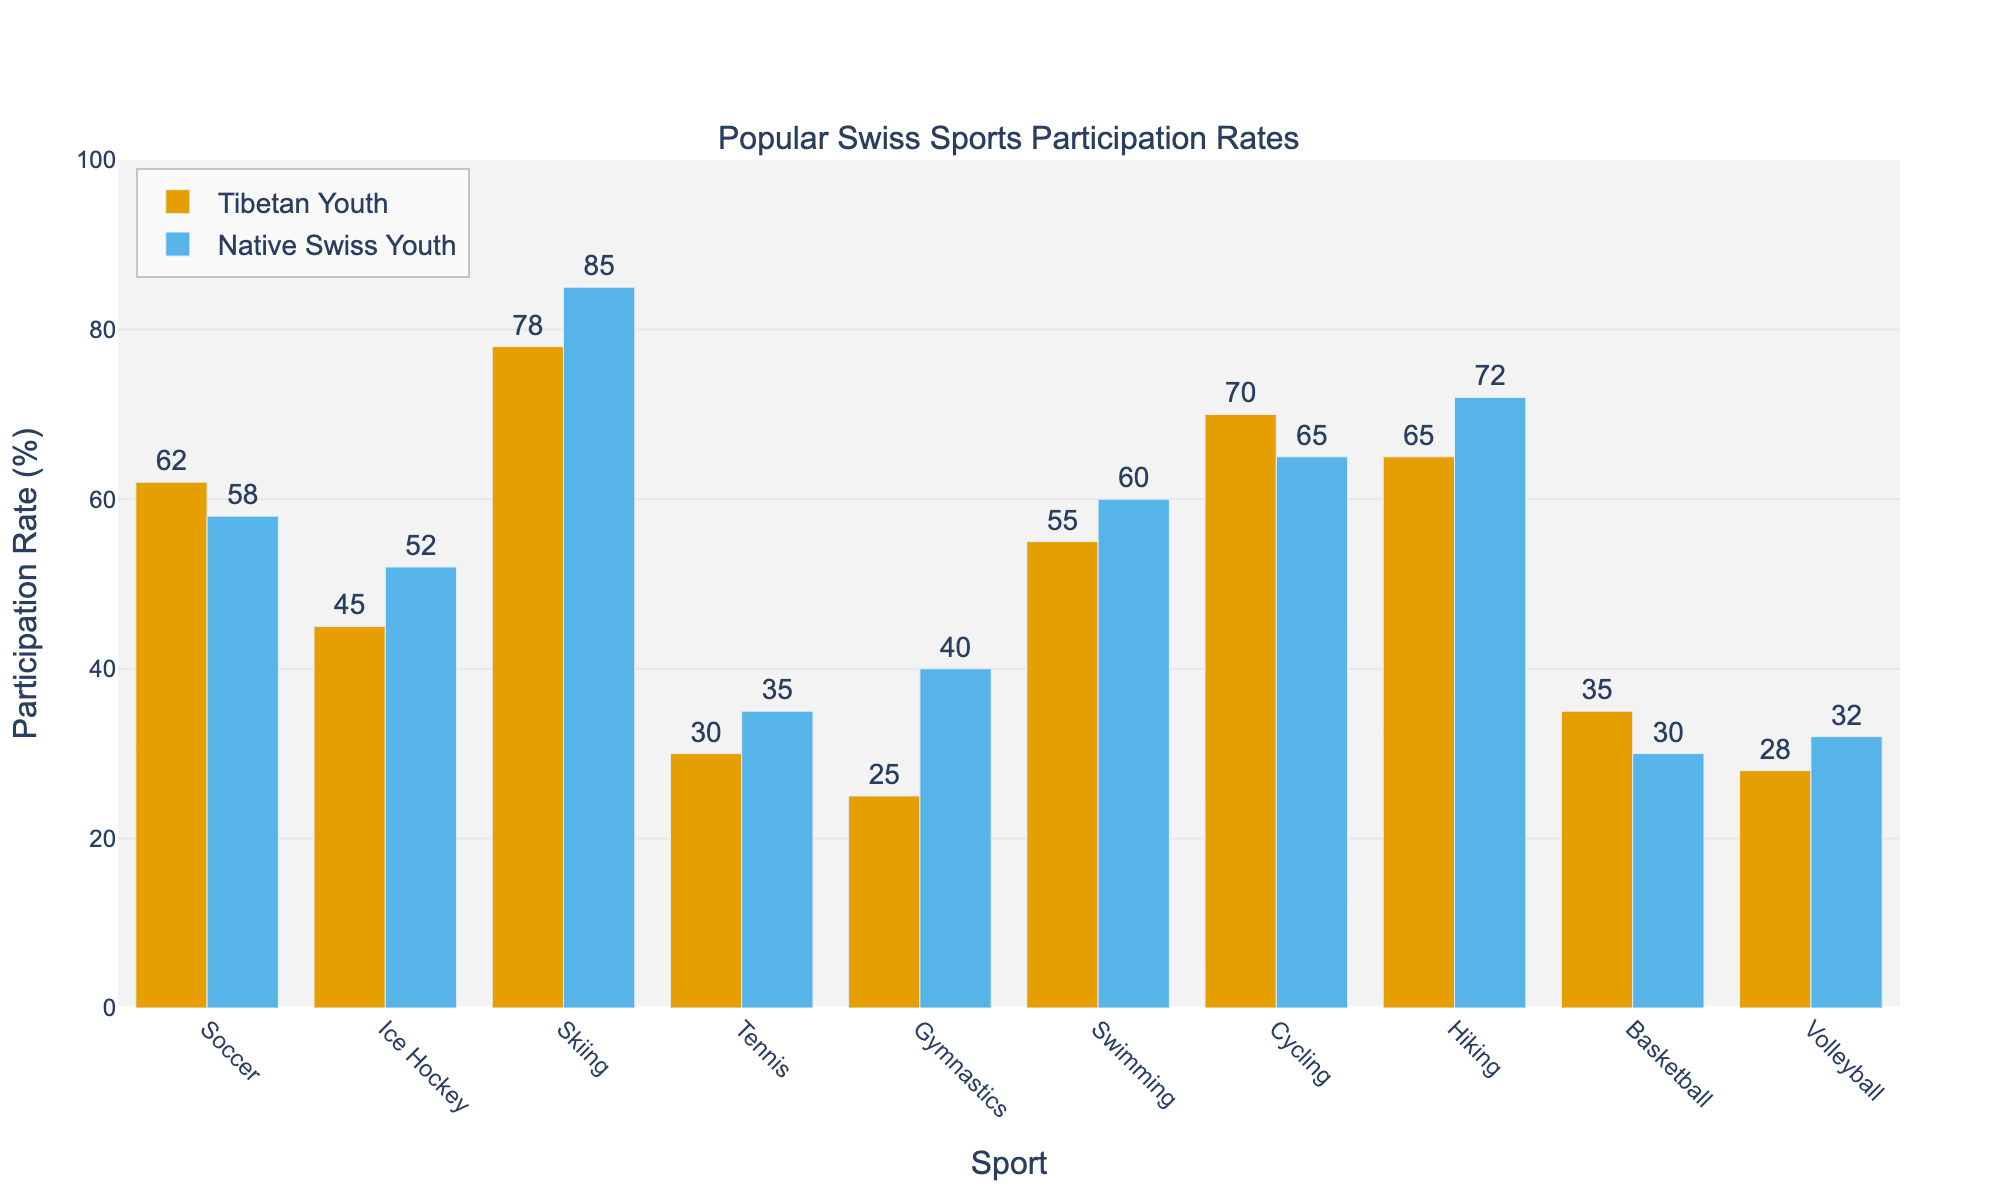Which sport has the highest participation rate among Tibetan youth? We look for the tallest bar representing Tibetan youth in the figure, which corresponds to the sport with the highest participation rate. The tallest bar among Tibetan youth is for Skiing, which has a participation rate of 78%.
Answer: Skiing Which group has a higher participation rate in basketball? We compare the heights of the two bars representing basketball. The Tibetan youth bar is taller, indicating a higher participation rate in basketball (35%) compared to native Swiss youth (30%).
Answer: Tibetan Youth What is the difference in participation rates for gymnastics between Tibetan and native Swiss youth? We subtract the participation rate of Tibetan youth (25%) from that of native Swiss youth (40%) for gymnastics. 40% - 25% = 15%.
Answer: 15% Which sport has the smallest difference in participation rates between Tibetan and native Swiss youth? We compare the absolute differences in participation rates for each sport. Basketball has the smallest difference:
Answer: Basketball What is the average participation rate for swimming across both groups? We add the participation rates for both groups for swimming (55% for Tibetan youth and 60% for native Swiss youth) and then divide the sum by 2: (55% + 60%) / 2 = 57.5%.
Answer: 57.5% Are there any sports where both groups have equal participation rates? We look for bars of equal height across all sports. There are no sports where the participation rates are equal between Tibetan youth and native Swiss youth.
Answer: No What is the total participation rate of soccer and cycling for Tibetan youth? We add the participation rates of soccer (62%) and cycling (70%) for Tibetan youth. 62% + 70% = 132%.
Answer: 132% For which sport is the participation rate higher for native Swiss youth than Tibetan youth by more than 10%? We subtract the participation rates of each sport for Tibetan youth from native Swiss youth. Gymnastics shows a larger than 10% difference: 40% (Native Swiss) - 25% (Tibetan) = 15%.
Answer: Gymnastics How does the participation rate for ice hockey differ between the two groups? We subtract the participation rate of Tibetan youth (45%) from the participation rate of native Swiss youth (52%) for ice hockey. 52% - 45% = 7%.
Answer: 7% Among the sports listed, how many have participation rates for Tibetan youth greater than 50%? We count the bars representing sports for Tibetan youth with percentages above 50%. Soccer (62%), Ice Hockey (45%), Skiing (78%), Swimming (55%), and Cycling (70%) have rates above 50%.
Answer: 5 